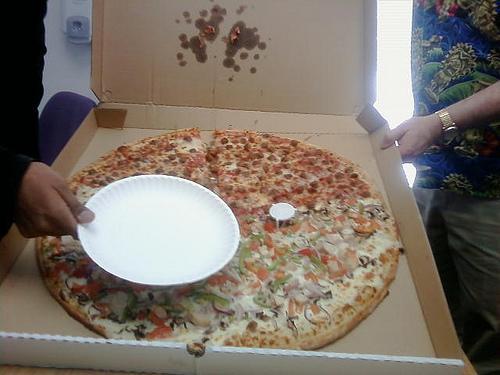How many pieces of pizza are eaten?
Give a very brief answer. 0. How many different types of pizza are on display?
Give a very brief answer. 2. How many people can you see?
Give a very brief answer. 2. 